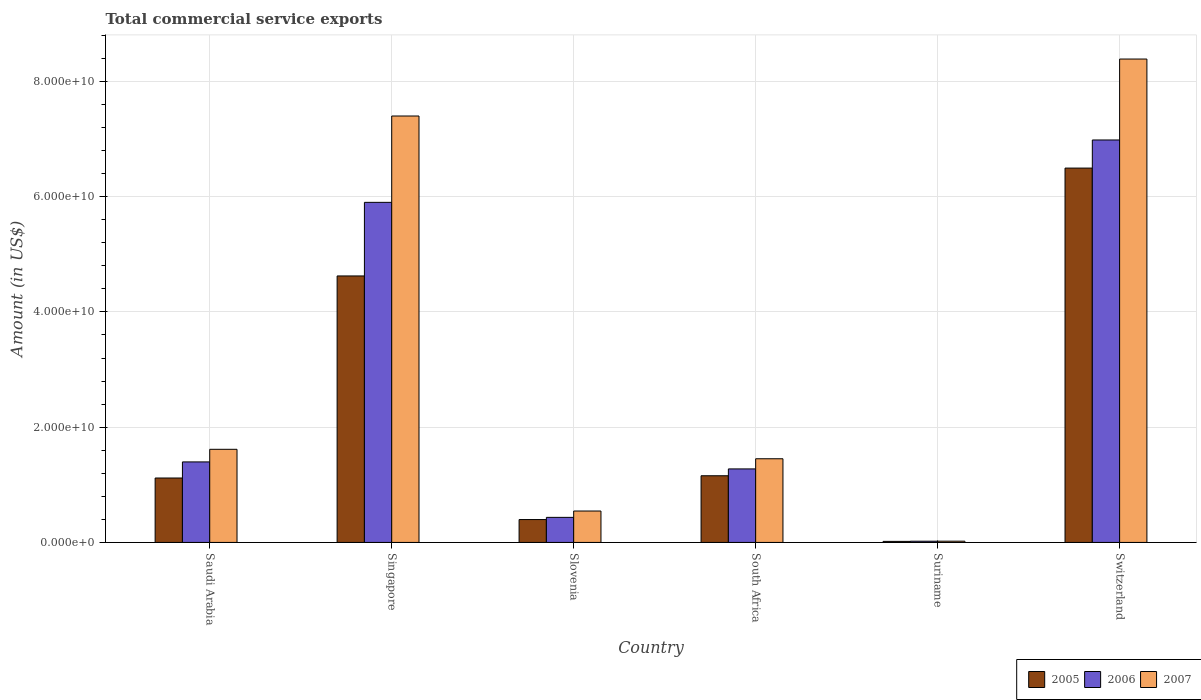How many groups of bars are there?
Keep it short and to the point. 6. Are the number of bars per tick equal to the number of legend labels?
Ensure brevity in your answer.  Yes. Are the number of bars on each tick of the X-axis equal?
Your answer should be compact. Yes. How many bars are there on the 2nd tick from the right?
Offer a terse response. 3. What is the label of the 3rd group of bars from the left?
Provide a short and direct response. Slovenia. In how many cases, is the number of bars for a given country not equal to the number of legend labels?
Offer a very short reply. 0. What is the total commercial service exports in 2006 in Slovenia?
Your response must be concise. 4.35e+09. Across all countries, what is the maximum total commercial service exports in 2007?
Provide a succinct answer. 8.39e+1. Across all countries, what is the minimum total commercial service exports in 2007?
Offer a very short reply. 2.19e+08. In which country was the total commercial service exports in 2005 maximum?
Your answer should be very brief. Switzerland. In which country was the total commercial service exports in 2006 minimum?
Provide a short and direct response. Suriname. What is the total total commercial service exports in 2005 in the graph?
Offer a very short reply. 1.38e+11. What is the difference between the total commercial service exports in 2006 in Saudi Arabia and that in Switzerland?
Provide a succinct answer. -5.59e+1. What is the difference between the total commercial service exports in 2005 in Slovenia and the total commercial service exports in 2007 in Saudi Arabia?
Offer a terse response. -1.22e+1. What is the average total commercial service exports in 2006 per country?
Your answer should be compact. 2.67e+1. What is the difference between the total commercial service exports of/in 2007 and total commercial service exports of/in 2005 in Saudi Arabia?
Ensure brevity in your answer.  4.98e+09. What is the ratio of the total commercial service exports in 2006 in Singapore to that in Suriname?
Ensure brevity in your answer.  276.28. Is the total commercial service exports in 2007 in Saudi Arabia less than that in South Africa?
Keep it short and to the point. No. What is the difference between the highest and the second highest total commercial service exports in 2006?
Give a very brief answer. 1.08e+1. What is the difference between the highest and the lowest total commercial service exports in 2006?
Keep it short and to the point. 6.96e+1. Is the sum of the total commercial service exports in 2006 in Singapore and South Africa greater than the maximum total commercial service exports in 2007 across all countries?
Provide a succinct answer. No. What does the 3rd bar from the left in Suriname represents?
Offer a terse response. 2007. Is it the case that in every country, the sum of the total commercial service exports in 2005 and total commercial service exports in 2006 is greater than the total commercial service exports in 2007?
Offer a terse response. Yes. Are all the bars in the graph horizontal?
Keep it short and to the point. No. How many countries are there in the graph?
Ensure brevity in your answer.  6. What is the difference between two consecutive major ticks on the Y-axis?
Provide a succinct answer. 2.00e+1. Are the values on the major ticks of Y-axis written in scientific E-notation?
Offer a very short reply. Yes. Does the graph contain any zero values?
Give a very brief answer. No. Does the graph contain grids?
Make the answer very short. Yes. How many legend labels are there?
Ensure brevity in your answer.  3. How are the legend labels stacked?
Ensure brevity in your answer.  Horizontal. What is the title of the graph?
Your answer should be very brief. Total commercial service exports. What is the label or title of the X-axis?
Provide a short and direct response. Country. What is the label or title of the Y-axis?
Offer a very short reply. Amount (in US$). What is the Amount (in US$) of 2005 in Saudi Arabia?
Your answer should be very brief. 1.12e+1. What is the Amount (in US$) in 2006 in Saudi Arabia?
Your answer should be very brief. 1.40e+1. What is the Amount (in US$) in 2007 in Saudi Arabia?
Your response must be concise. 1.62e+1. What is the Amount (in US$) of 2005 in Singapore?
Provide a short and direct response. 4.62e+1. What is the Amount (in US$) in 2006 in Singapore?
Keep it short and to the point. 5.90e+1. What is the Amount (in US$) in 2007 in Singapore?
Provide a succinct answer. 7.40e+1. What is the Amount (in US$) of 2005 in Slovenia?
Offer a terse response. 3.97e+09. What is the Amount (in US$) of 2006 in Slovenia?
Offer a terse response. 4.35e+09. What is the Amount (in US$) in 2007 in Slovenia?
Provide a succinct answer. 5.45e+09. What is the Amount (in US$) of 2005 in South Africa?
Provide a succinct answer. 1.16e+1. What is the Amount (in US$) in 2006 in South Africa?
Keep it short and to the point. 1.28e+1. What is the Amount (in US$) of 2007 in South Africa?
Ensure brevity in your answer.  1.45e+1. What is the Amount (in US$) of 2005 in Suriname?
Provide a succinct answer. 1.83e+08. What is the Amount (in US$) of 2006 in Suriname?
Your answer should be compact. 2.14e+08. What is the Amount (in US$) in 2007 in Suriname?
Your answer should be very brief. 2.19e+08. What is the Amount (in US$) in 2005 in Switzerland?
Your response must be concise. 6.50e+1. What is the Amount (in US$) of 2006 in Switzerland?
Your answer should be very brief. 6.98e+1. What is the Amount (in US$) in 2007 in Switzerland?
Give a very brief answer. 8.39e+1. Across all countries, what is the maximum Amount (in US$) of 2005?
Provide a succinct answer. 6.50e+1. Across all countries, what is the maximum Amount (in US$) of 2006?
Keep it short and to the point. 6.98e+1. Across all countries, what is the maximum Amount (in US$) in 2007?
Give a very brief answer. 8.39e+1. Across all countries, what is the minimum Amount (in US$) in 2005?
Ensure brevity in your answer.  1.83e+08. Across all countries, what is the minimum Amount (in US$) of 2006?
Your response must be concise. 2.14e+08. Across all countries, what is the minimum Amount (in US$) in 2007?
Make the answer very short. 2.19e+08. What is the total Amount (in US$) in 2005 in the graph?
Provide a short and direct response. 1.38e+11. What is the total Amount (in US$) of 2006 in the graph?
Give a very brief answer. 1.60e+11. What is the total Amount (in US$) of 2007 in the graph?
Your response must be concise. 1.94e+11. What is the difference between the Amount (in US$) of 2005 in Saudi Arabia and that in Singapore?
Your response must be concise. -3.51e+1. What is the difference between the Amount (in US$) of 2006 in Saudi Arabia and that in Singapore?
Your answer should be very brief. -4.50e+1. What is the difference between the Amount (in US$) of 2007 in Saudi Arabia and that in Singapore?
Keep it short and to the point. -5.78e+1. What is the difference between the Amount (in US$) of 2005 in Saudi Arabia and that in Slovenia?
Keep it short and to the point. 7.21e+09. What is the difference between the Amount (in US$) in 2006 in Saudi Arabia and that in Slovenia?
Make the answer very short. 9.62e+09. What is the difference between the Amount (in US$) in 2007 in Saudi Arabia and that in Slovenia?
Your response must be concise. 1.07e+1. What is the difference between the Amount (in US$) of 2005 in Saudi Arabia and that in South Africa?
Your answer should be very brief. -3.91e+08. What is the difference between the Amount (in US$) of 2006 in Saudi Arabia and that in South Africa?
Provide a succinct answer. 1.22e+09. What is the difference between the Amount (in US$) of 2007 in Saudi Arabia and that in South Africa?
Ensure brevity in your answer.  1.64e+09. What is the difference between the Amount (in US$) of 2005 in Saudi Arabia and that in Suriname?
Ensure brevity in your answer.  1.10e+1. What is the difference between the Amount (in US$) in 2006 in Saudi Arabia and that in Suriname?
Provide a short and direct response. 1.38e+1. What is the difference between the Amount (in US$) of 2007 in Saudi Arabia and that in Suriname?
Provide a short and direct response. 1.59e+1. What is the difference between the Amount (in US$) in 2005 in Saudi Arabia and that in Switzerland?
Your answer should be compact. -5.38e+1. What is the difference between the Amount (in US$) of 2006 in Saudi Arabia and that in Switzerland?
Give a very brief answer. -5.59e+1. What is the difference between the Amount (in US$) in 2007 in Saudi Arabia and that in Switzerland?
Make the answer very short. -6.77e+1. What is the difference between the Amount (in US$) in 2005 in Singapore and that in Slovenia?
Keep it short and to the point. 4.23e+1. What is the difference between the Amount (in US$) of 2006 in Singapore and that in Slovenia?
Provide a succinct answer. 5.47e+1. What is the difference between the Amount (in US$) in 2007 in Singapore and that in Slovenia?
Your response must be concise. 6.85e+1. What is the difference between the Amount (in US$) of 2005 in Singapore and that in South Africa?
Give a very brief answer. 3.47e+1. What is the difference between the Amount (in US$) in 2006 in Singapore and that in South Africa?
Ensure brevity in your answer.  4.63e+1. What is the difference between the Amount (in US$) in 2007 in Singapore and that in South Africa?
Your answer should be compact. 5.95e+1. What is the difference between the Amount (in US$) of 2005 in Singapore and that in Suriname?
Make the answer very short. 4.61e+1. What is the difference between the Amount (in US$) in 2006 in Singapore and that in Suriname?
Give a very brief answer. 5.88e+1. What is the difference between the Amount (in US$) of 2007 in Singapore and that in Suriname?
Offer a very short reply. 7.38e+1. What is the difference between the Amount (in US$) of 2005 in Singapore and that in Switzerland?
Your answer should be very brief. -1.87e+1. What is the difference between the Amount (in US$) in 2006 in Singapore and that in Switzerland?
Provide a succinct answer. -1.08e+1. What is the difference between the Amount (in US$) of 2007 in Singapore and that in Switzerland?
Keep it short and to the point. -9.89e+09. What is the difference between the Amount (in US$) in 2005 in Slovenia and that in South Africa?
Make the answer very short. -7.60e+09. What is the difference between the Amount (in US$) in 2006 in Slovenia and that in South Africa?
Provide a succinct answer. -8.41e+09. What is the difference between the Amount (in US$) in 2007 in Slovenia and that in South Africa?
Give a very brief answer. -9.07e+09. What is the difference between the Amount (in US$) in 2005 in Slovenia and that in Suriname?
Provide a succinct answer. 3.79e+09. What is the difference between the Amount (in US$) of 2006 in Slovenia and that in Suriname?
Provide a short and direct response. 4.14e+09. What is the difference between the Amount (in US$) in 2007 in Slovenia and that in Suriname?
Your answer should be very brief. 5.23e+09. What is the difference between the Amount (in US$) of 2005 in Slovenia and that in Switzerland?
Your answer should be compact. -6.10e+1. What is the difference between the Amount (in US$) of 2006 in Slovenia and that in Switzerland?
Your answer should be very brief. -6.55e+1. What is the difference between the Amount (in US$) in 2007 in Slovenia and that in Switzerland?
Make the answer very short. -7.84e+1. What is the difference between the Amount (in US$) in 2005 in South Africa and that in Suriname?
Provide a succinct answer. 1.14e+1. What is the difference between the Amount (in US$) in 2006 in South Africa and that in Suriname?
Your answer should be compact. 1.25e+1. What is the difference between the Amount (in US$) in 2007 in South Africa and that in Suriname?
Your answer should be compact. 1.43e+1. What is the difference between the Amount (in US$) in 2005 in South Africa and that in Switzerland?
Provide a succinct answer. -5.34e+1. What is the difference between the Amount (in US$) of 2006 in South Africa and that in Switzerland?
Your answer should be very brief. -5.71e+1. What is the difference between the Amount (in US$) of 2007 in South Africa and that in Switzerland?
Your answer should be very brief. -6.94e+1. What is the difference between the Amount (in US$) of 2005 in Suriname and that in Switzerland?
Provide a succinct answer. -6.48e+1. What is the difference between the Amount (in US$) in 2006 in Suriname and that in Switzerland?
Provide a succinct answer. -6.96e+1. What is the difference between the Amount (in US$) of 2007 in Suriname and that in Switzerland?
Your answer should be compact. -8.37e+1. What is the difference between the Amount (in US$) in 2005 in Saudi Arabia and the Amount (in US$) in 2006 in Singapore?
Give a very brief answer. -4.78e+1. What is the difference between the Amount (in US$) of 2005 in Saudi Arabia and the Amount (in US$) of 2007 in Singapore?
Offer a very short reply. -6.28e+1. What is the difference between the Amount (in US$) of 2006 in Saudi Arabia and the Amount (in US$) of 2007 in Singapore?
Make the answer very short. -6.00e+1. What is the difference between the Amount (in US$) of 2005 in Saudi Arabia and the Amount (in US$) of 2006 in Slovenia?
Offer a very short reply. 6.83e+09. What is the difference between the Amount (in US$) in 2005 in Saudi Arabia and the Amount (in US$) in 2007 in Slovenia?
Provide a short and direct response. 5.73e+09. What is the difference between the Amount (in US$) in 2006 in Saudi Arabia and the Amount (in US$) in 2007 in Slovenia?
Your response must be concise. 8.52e+09. What is the difference between the Amount (in US$) of 2005 in Saudi Arabia and the Amount (in US$) of 2006 in South Africa?
Offer a very short reply. -1.58e+09. What is the difference between the Amount (in US$) of 2005 in Saudi Arabia and the Amount (in US$) of 2007 in South Africa?
Offer a very short reply. -3.34e+09. What is the difference between the Amount (in US$) of 2006 in Saudi Arabia and the Amount (in US$) of 2007 in South Africa?
Your answer should be very brief. -5.46e+08. What is the difference between the Amount (in US$) of 2005 in Saudi Arabia and the Amount (in US$) of 2006 in Suriname?
Offer a terse response. 1.10e+1. What is the difference between the Amount (in US$) in 2005 in Saudi Arabia and the Amount (in US$) in 2007 in Suriname?
Offer a terse response. 1.10e+1. What is the difference between the Amount (in US$) in 2006 in Saudi Arabia and the Amount (in US$) in 2007 in Suriname?
Provide a succinct answer. 1.38e+1. What is the difference between the Amount (in US$) in 2005 in Saudi Arabia and the Amount (in US$) in 2006 in Switzerland?
Make the answer very short. -5.87e+1. What is the difference between the Amount (in US$) in 2005 in Saudi Arabia and the Amount (in US$) in 2007 in Switzerland?
Provide a succinct answer. -7.27e+1. What is the difference between the Amount (in US$) of 2006 in Saudi Arabia and the Amount (in US$) of 2007 in Switzerland?
Offer a very short reply. -6.99e+1. What is the difference between the Amount (in US$) of 2005 in Singapore and the Amount (in US$) of 2006 in Slovenia?
Offer a terse response. 4.19e+1. What is the difference between the Amount (in US$) in 2005 in Singapore and the Amount (in US$) in 2007 in Slovenia?
Provide a short and direct response. 4.08e+1. What is the difference between the Amount (in US$) of 2006 in Singapore and the Amount (in US$) of 2007 in Slovenia?
Your response must be concise. 5.36e+1. What is the difference between the Amount (in US$) in 2005 in Singapore and the Amount (in US$) in 2006 in South Africa?
Keep it short and to the point. 3.35e+1. What is the difference between the Amount (in US$) of 2005 in Singapore and the Amount (in US$) of 2007 in South Africa?
Provide a short and direct response. 3.17e+1. What is the difference between the Amount (in US$) in 2006 in Singapore and the Amount (in US$) in 2007 in South Africa?
Keep it short and to the point. 4.45e+1. What is the difference between the Amount (in US$) in 2005 in Singapore and the Amount (in US$) in 2006 in Suriname?
Provide a succinct answer. 4.60e+1. What is the difference between the Amount (in US$) of 2005 in Singapore and the Amount (in US$) of 2007 in Suriname?
Give a very brief answer. 4.60e+1. What is the difference between the Amount (in US$) of 2006 in Singapore and the Amount (in US$) of 2007 in Suriname?
Make the answer very short. 5.88e+1. What is the difference between the Amount (in US$) in 2005 in Singapore and the Amount (in US$) in 2006 in Switzerland?
Make the answer very short. -2.36e+1. What is the difference between the Amount (in US$) in 2005 in Singapore and the Amount (in US$) in 2007 in Switzerland?
Give a very brief answer. -3.76e+1. What is the difference between the Amount (in US$) in 2006 in Singapore and the Amount (in US$) in 2007 in Switzerland?
Offer a terse response. -2.49e+1. What is the difference between the Amount (in US$) in 2005 in Slovenia and the Amount (in US$) in 2006 in South Africa?
Provide a short and direct response. -8.79e+09. What is the difference between the Amount (in US$) in 2005 in Slovenia and the Amount (in US$) in 2007 in South Africa?
Offer a terse response. -1.05e+1. What is the difference between the Amount (in US$) in 2006 in Slovenia and the Amount (in US$) in 2007 in South Africa?
Your answer should be compact. -1.02e+1. What is the difference between the Amount (in US$) of 2005 in Slovenia and the Amount (in US$) of 2006 in Suriname?
Your answer should be very brief. 3.76e+09. What is the difference between the Amount (in US$) of 2005 in Slovenia and the Amount (in US$) of 2007 in Suriname?
Ensure brevity in your answer.  3.75e+09. What is the difference between the Amount (in US$) in 2006 in Slovenia and the Amount (in US$) in 2007 in Suriname?
Offer a terse response. 4.13e+09. What is the difference between the Amount (in US$) in 2005 in Slovenia and the Amount (in US$) in 2006 in Switzerland?
Give a very brief answer. -6.59e+1. What is the difference between the Amount (in US$) in 2005 in Slovenia and the Amount (in US$) in 2007 in Switzerland?
Give a very brief answer. -7.99e+1. What is the difference between the Amount (in US$) in 2006 in Slovenia and the Amount (in US$) in 2007 in Switzerland?
Make the answer very short. -7.95e+1. What is the difference between the Amount (in US$) of 2005 in South Africa and the Amount (in US$) of 2006 in Suriname?
Provide a short and direct response. 1.14e+1. What is the difference between the Amount (in US$) of 2005 in South Africa and the Amount (in US$) of 2007 in Suriname?
Offer a very short reply. 1.14e+1. What is the difference between the Amount (in US$) of 2006 in South Africa and the Amount (in US$) of 2007 in Suriname?
Offer a very short reply. 1.25e+1. What is the difference between the Amount (in US$) of 2005 in South Africa and the Amount (in US$) of 2006 in Switzerland?
Give a very brief answer. -5.83e+1. What is the difference between the Amount (in US$) in 2005 in South Africa and the Amount (in US$) in 2007 in Switzerland?
Your answer should be very brief. -7.23e+1. What is the difference between the Amount (in US$) in 2006 in South Africa and the Amount (in US$) in 2007 in Switzerland?
Offer a terse response. -7.11e+1. What is the difference between the Amount (in US$) of 2005 in Suriname and the Amount (in US$) of 2006 in Switzerland?
Your answer should be compact. -6.97e+1. What is the difference between the Amount (in US$) in 2005 in Suriname and the Amount (in US$) in 2007 in Switzerland?
Ensure brevity in your answer.  -8.37e+1. What is the difference between the Amount (in US$) in 2006 in Suriname and the Amount (in US$) in 2007 in Switzerland?
Your response must be concise. -8.37e+1. What is the average Amount (in US$) of 2005 per country?
Keep it short and to the point. 2.30e+1. What is the average Amount (in US$) of 2006 per country?
Provide a succinct answer. 2.67e+1. What is the average Amount (in US$) in 2007 per country?
Offer a very short reply. 3.24e+1. What is the difference between the Amount (in US$) of 2005 and Amount (in US$) of 2006 in Saudi Arabia?
Offer a terse response. -2.79e+09. What is the difference between the Amount (in US$) of 2005 and Amount (in US$) of 2007 in Saudi Arabia?
Give a very brief answer. -4.98e+09. What is the difference between the Amount (in US$) of 2006 and Amount (in US$) of 2007 in Saudi Arabia?
Your answer should be compact. -2.19e+09. What is the difference between the Amount (in US$) in 2005 and Amount (in US$) in 2006 in Singapore?
Offer a terse response. -1.28e+1. What is the difference between the Amount (in US$) in 2005 and Amount (in US$) in 2007 in Singapore?
Offer a terse response. -2.78e+1. What is the difference between the Amount (in US$) in 2006 and Amount (in US$) in 2007 in Singapore?
Your answer should be very brief. -1.50e+1. What is the difference between the Amount (in US$) of 2005 and Amount (in US$) of 2006 in Slovenia?
Offer a terse response. -3.80e+08. What is the difference between the Amount (in US$) in 2005 and Amount (in US$) in 2007 in Slovenia?
Make the answer very short. -1.48e+09. What is the difference between the Amount (in US$) in 2006 and Amount (in US$) in 2007 in Slovenia?
Provide a short and direct response. -1.10e+09. What is the difference between the Amount (in US$) of 2005 and Amount (in US$) of 2006 in South Africa?
Offer a terse response. -1.19e+09. What is the difference between the Amount (in US$) in 2005 and Amount (in US$) in 2007 in South Africa?
Your answer should be very brief. -2.95e+09. What is the difference between the Amount (in US$) in 2006 and Amount (in US$) in 2007 in South Africa?
Provide a short and direct response. -1.76e+09. What is the difference between the Amount (in US$) in 2005 and Amount (in US$) in 2006 in Suriname?
Provide a short and direct response. -3.10e+07. What is the difference between the Amount (in US$) in 2005 and Amount (in US$) in 2007 in Suriname?
Offer a very short reply. -3.61e+07. What is the difference between the Amount (in US$) of 2006 and Amount (in US$) of 2007 in Suriname?
Provide a short and direct response. -5.10e+06. What is the difference between the Amount (in US$) in 2005 and Amount (in US$) in 2006 in Switzerland?
Provide a succinct answer. -4.88e+09. What is the difference between the Amount (in US$) in 2005 and Amount (in US$) in 2007 in Switzerland?
Your answer should be very brief. -1.89e+1. What is the difference between the Amount (in US$) in 2006 and Amount (in US$) in 2007 in Switzerland?
Offer a very short reply. -1.40e+1. What is the ratio of the Amount (in US$) of 2005 in Saudi Arabia to that in Singapore?
Your response must be concise. 0.24. What is the ratio of the Amount (in US$) in 2006 in Saudi Arabia to that in Singapore?
Make the answer very short. 0.24. What is the ratio of the Amount (in US$) of 2007 in Saudi Arabia to that in Singapore?
Your answer should be very brief. 0.22. What is the ratio of the Amount (in US$) in 2005 in Saudi Arabia to that in Slovenia?
Your answer should be very brief. 2.82. What is the ratio of the Amount (in US$) in 2006 in Saudi Arabia to that in Slovenia?
Ensure brevity in your answer.  3.21. What is the ratio of the Amount (in US$) of 2007 in Saudi Arabia to that in Slovenia?
Provide a short and direct response. 2.96. What is the ratio of the Amount (in US$) of 2005 in Saudi Arabia to that in South Africa?
Offer a terse response. 0.97. What is the ratio of the Amount (in US$) of 2006 in Saudi Arabia to that in South Africa?
Offer a very short reply. 1.1. What is the ratio of the Amount (in US$) of 2007 in Saudi Arabia to that in South Africa?
Offer a terse response. 1.11. What is the ratio of the Amount (in US$) in 2005 in Saudi Arabia to that in Suriname?
Ensure brevity in your answer.  61.22. What is the ratio of the Amount (in US$) of 2006 in Saudi Arabia to that in Suriname?
Your answer should be very brief. 65.42. What is the ratio of the Amount (in US$) in 2007 in Saudi Arabia to that in Suriname?
Keep it short and to the point. 73.89. What is the ratio of the Amount (in US$) in 2005 in Saudi Arabia to that in Switzerland?
Provide a succinct answer. 0.17. What is the ratio of the Amount (in US$) of 2006 in Saudi Arabia to that in Switzerland?
Your answer should be very brief. 0.2. What is the ratio of the Amount (in US$) in 2007 in Saudi Arabia to that in Switzerland?
Provide a succinct answer. 0.19. What is the ratio of the Amount (in US$) in 2005 in Singapore to that in Slovenia?
Keep it short and to the point. 11.65. What is the ratio of the Amount (in US$) in 2006 in Singapore to that in Slovenia?
Your answer should be compact. 13.57. What is the ratio of the Amount (in US$) in 2007 in Singapore to that in Slovenia?
Ensure brevity in your answer.  13.58. What is the ratio of the Amount (in US$) in 2005 in Singapore to that in South Africa?
Offer a terse response. 4. What is the ratio of the Amount (in US$) of 2006 in Singapore to that in South Africa?
Keep it short and to the point. 4.63. What is the ratio of the Amount (in US$) in 2007 in Singapore to that in South Africa?
Keep it short and to the point. 5.1. What is the ratio of the Amount (in US$) of 2005 in Singapore to that in Suriname?
Ensure brevity in your answer.  253.25. What is the ratio of the Amount (in US$) in 2006 in Singapore to that in Suriname?
Your answer should be very brief. 276.28. What is the ratio of the Amount (in US$) in 2007 in Singapore to that in Suriname?
Provide a succinct answer. 338.34. What is the ratio of the Amount (in US$) in 2005 in Singapore to that in Switzerland?
Offer a very short reply. 0.71. What is the ratio of the Amount (in US$) of 2006 in Singapore to that in Switzerland?
Offer a terse response. 0.84. What is the ratio of the Amount (in US$) in 2007 in Singapore to that in Switzerland?
Make the answer very short. 0.88. What is the ratio of the Amount (in US$) of 2005 in Slovenia to that in South Africa?
Offer a terse response. 0.34. What is the ratio of the Amount (in US$) of 2006 in Slovenia to that in South Africa?
Ensure brevity in your answer.  0.34. What is the ratio of the Amount (in US$) in 2007 in Slovenia to that in South Africa?
Your answer should be compact. 0.38. What is the ratio of the Amount (in US$) in 2005 in Slovenia to that in Suriname?
Your answer should be compact. 21.74. What is the ratio of the Amount (in US$) of 2006 in Slovenia to that in Suriname?
Offer a terse response. 20.36. What is the ratio of the Amount (in US$) of 2007 in Slovenia to that in Suriname?
Offer a very short reply. 24.92. What is the ratio of the Amount (in US$) in 2005 in Slovenia to that in Switzerland?
Ensure brevity in your answer.  0.06. What is the ratio of the Amount (in US$) of 2006 in Slovenia to that in Switzerland?
Your answer should be compact. 0.06. What is the ratio of the Amount (in US$) of 2007 in Slovenia to that in Switzerland?
Give a very brief answer. 0.07. What is the ratio of the Amount (in US$) in 2005 in South Africa to that in Suriname?
Provide a succinct answer. 63.36. What is the ratio of the Amount (in US$) in 2006 in South Africa to that in Suriname?
Keep it short and to the point. 59.72. What is the ratio of the Amount (in US$) in 2007 in South Africa to that in Suriname?
Give a very brief answer. 66.39. What is the ratio of the Amount (in US$) of 2005 in South Africa to that in Switzerland?
Provide a succinct answer. 0.18. What is the ratio of the Amount (in US$) of 2006 in South Africa to that in Switzerland?
Your answer should be very brief. 0.18. What is the ratio of the Amount (in US$) of 2007 in South Africa to that in Switzerland?
Offer a very short reply. 0.17. What is the ratio of the Amount (in US$) of 2005 in Suriname to that in Switzerland?
Offer a very short reply. 0. What is the ratio of the Amount (in US$) of 2006 in Suriname to that in Switzerland?
Ensure brevity in your answer.  0. What is the ratio of the Amount (in US$) of 2007 in Suriname to that in Switzerland?
Offer a terse response. 0. What is the difference between the highest and the second highest Amount (in US$) of 2005?
Offer a very short reply. 1.87e+1. What is the difference between the highest and the second highest Amount (in US$) in 2006?
Offer a terse response. 1.08e+1. What is the difference between the highest and the second highest Amount (in US$) in 2007?
Offer a very short reply. 9.89e+09. What is the difference between the highest and the lowest Amount (in US$) of 2005?
Keep it short and to the point. 6.48e+1. What is the difference between the highest and the lowest Amount (in US$) of 2006?
Keep it short and to the point. 6.96e+1. What is the difference between the highest and the lowest Amount (in US$) of 2007?
Provide a short and direct response. 8.37e+1. 